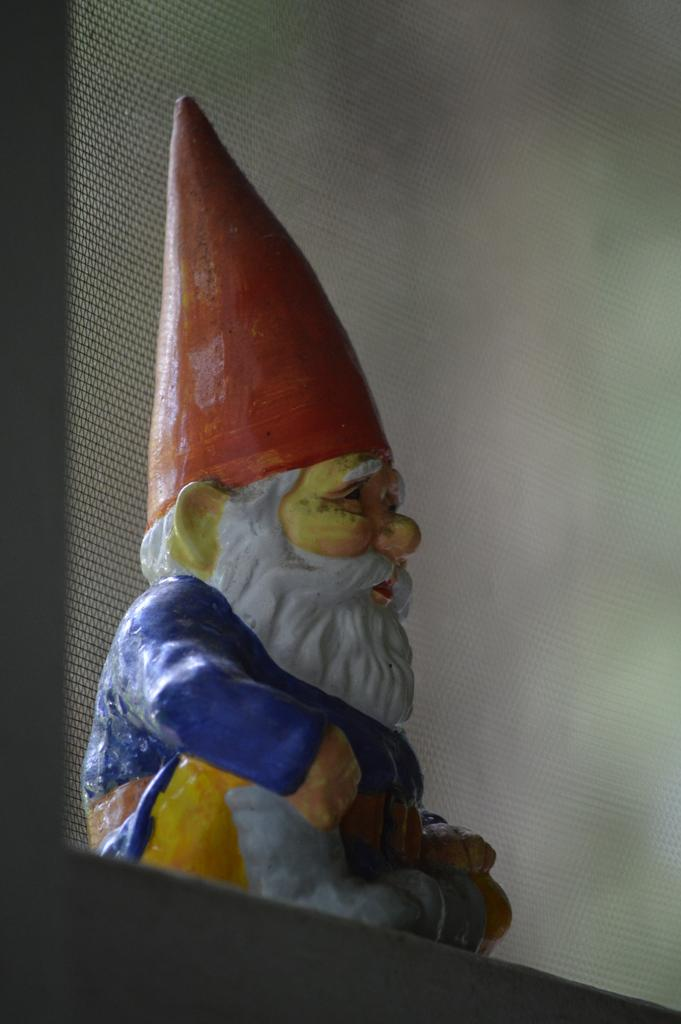What is the main subject in the center of the image? There is a sculpture in the center of the image. What type of creature is holding an umbrella in the image? There is no creature holding an umbrella present in the image; it features a sculpture in the center. 